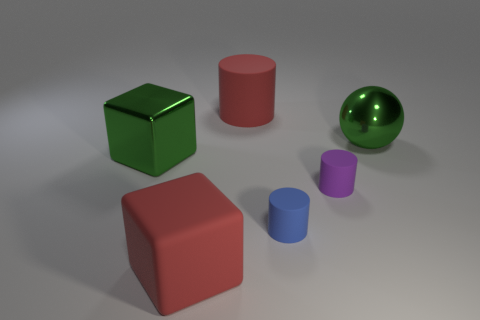Subtract all small matte cylinders. How many cylinders are left? 1 Subtract 1 cylinders. How many cylinders are left? 2 Subtract all red cylinders. How many cylinders are left? 2 Add 4 tiny purple matte cylinders. How many objects exist? 10 Subtract all cubes. How many objects are left? 4 Add 2 big spheres. How many big spheres are left? 3 Add 5 tiny matte cubes. How many tiny matte cubes exist? 5 Subtract 0 red balls. How many objects are left? 6 Subtract all purple cylinders. Subtract all red spheres. How many cylinders are left? 2 Subtract all big balls. Subtract all matte blocks. How many objects are left? 4 